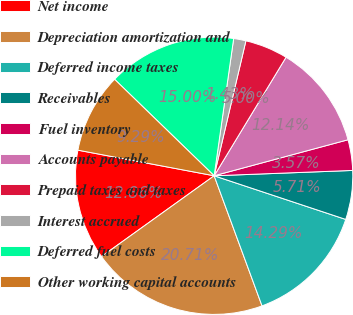Convert chart. <chart><loc_0><loc_0><loc_500><loc_500><pie_chart><fcel>Net income<fcel>Depreciation amortization and<fcel>Deferred income taxes<fcel>Receivables<fcel>Fuel inventory<fcel>Accounts payable<fcel>Prepaid taxes and taxes<fcel>Interest accrued<fcel>Deferred fuel costs<fcel>Other working capital accounts<nl><fcel>12.86%<fcel>20.71%<fcel>14.29%<fcel>5.71%<fcel>3.57%<fcel>12.14%<fcel>5.0%<fcel>1.43%<fcel>15.0%<fcel>9.29%<nl></chart> 